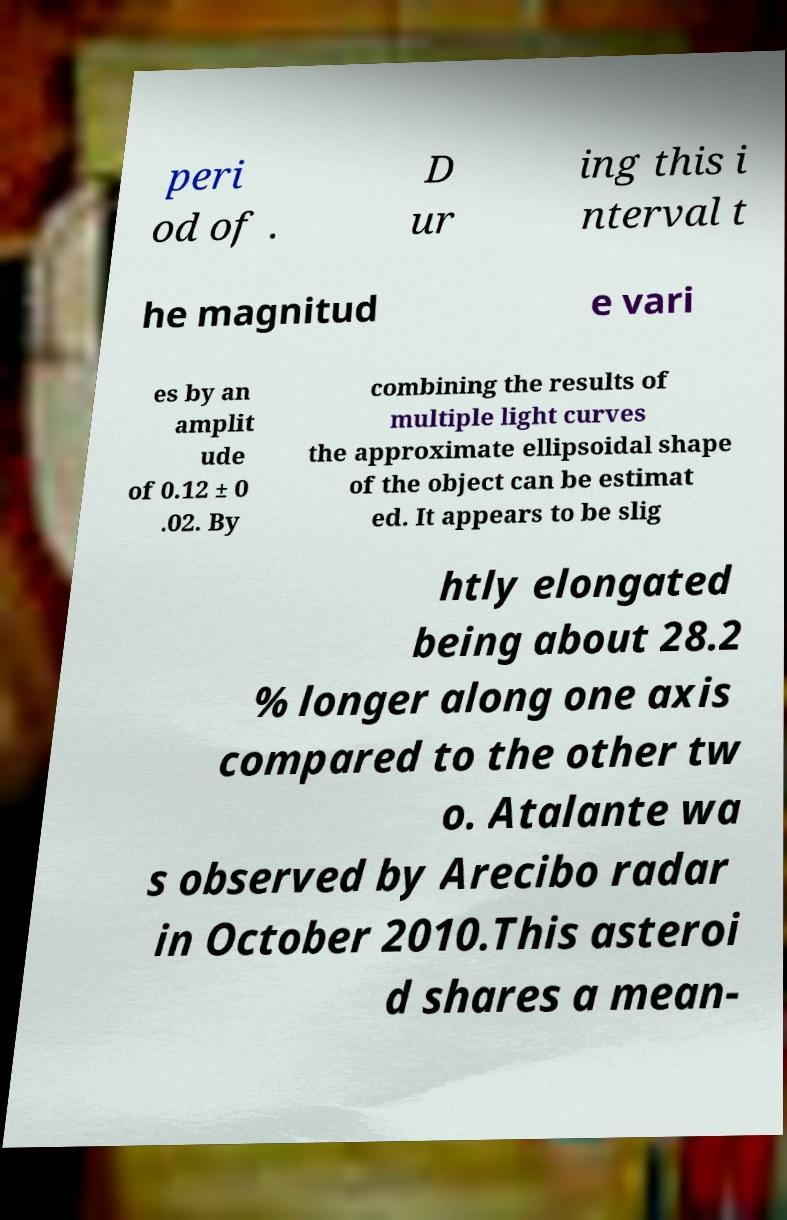Could you assist in decoding the text presented in this image and type it out clearly? peri od of . D ur ing this i nterval t he magnitud e vari es by an amplit ude of 0.12 ± 0 .02. By combining the results of multiple light curves the approximate ellipsoidal shape of the object can be estimat ed. It appears to be slig htly elongated being about 28.2 % longer along one axis compared to the other tw o. Atalante wa s observed by Arecibo radar in October 2010.This asteroi d shares a mean- 